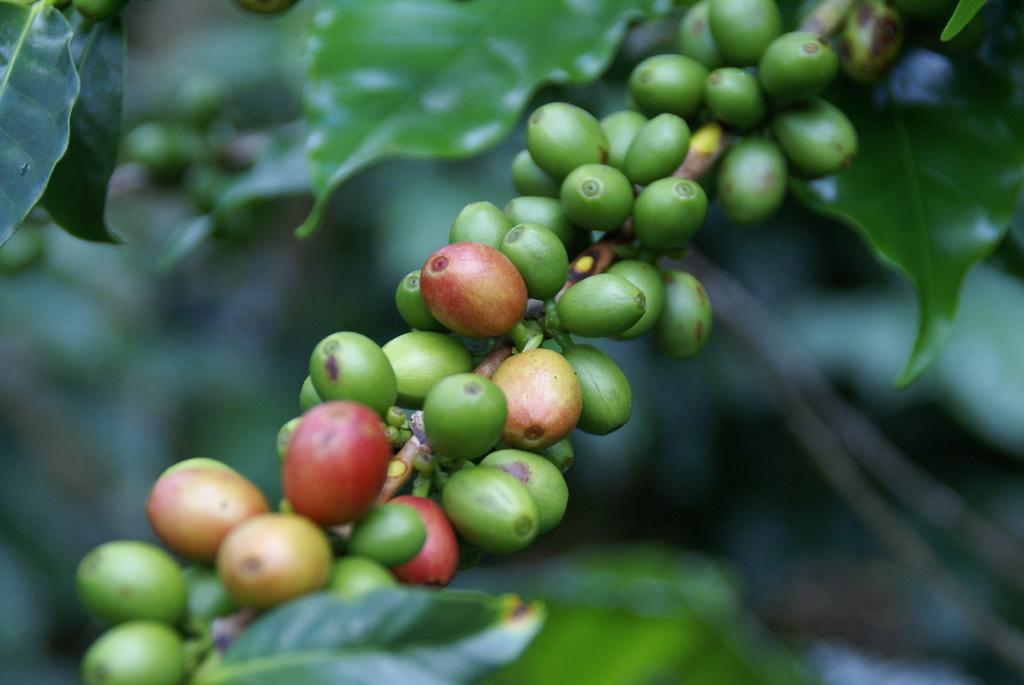What type of beans are visible in the image? There are coffee beans in the image. What other plant-related items can be seen in the image? There are green leaves in the image. How would you describe the background of the image? The background of the image is blurred. What type of riddle is being solved by the coffee beans in the image? There is no riddle being solved by the coffee beans in the image; they are simply visible in the image. 